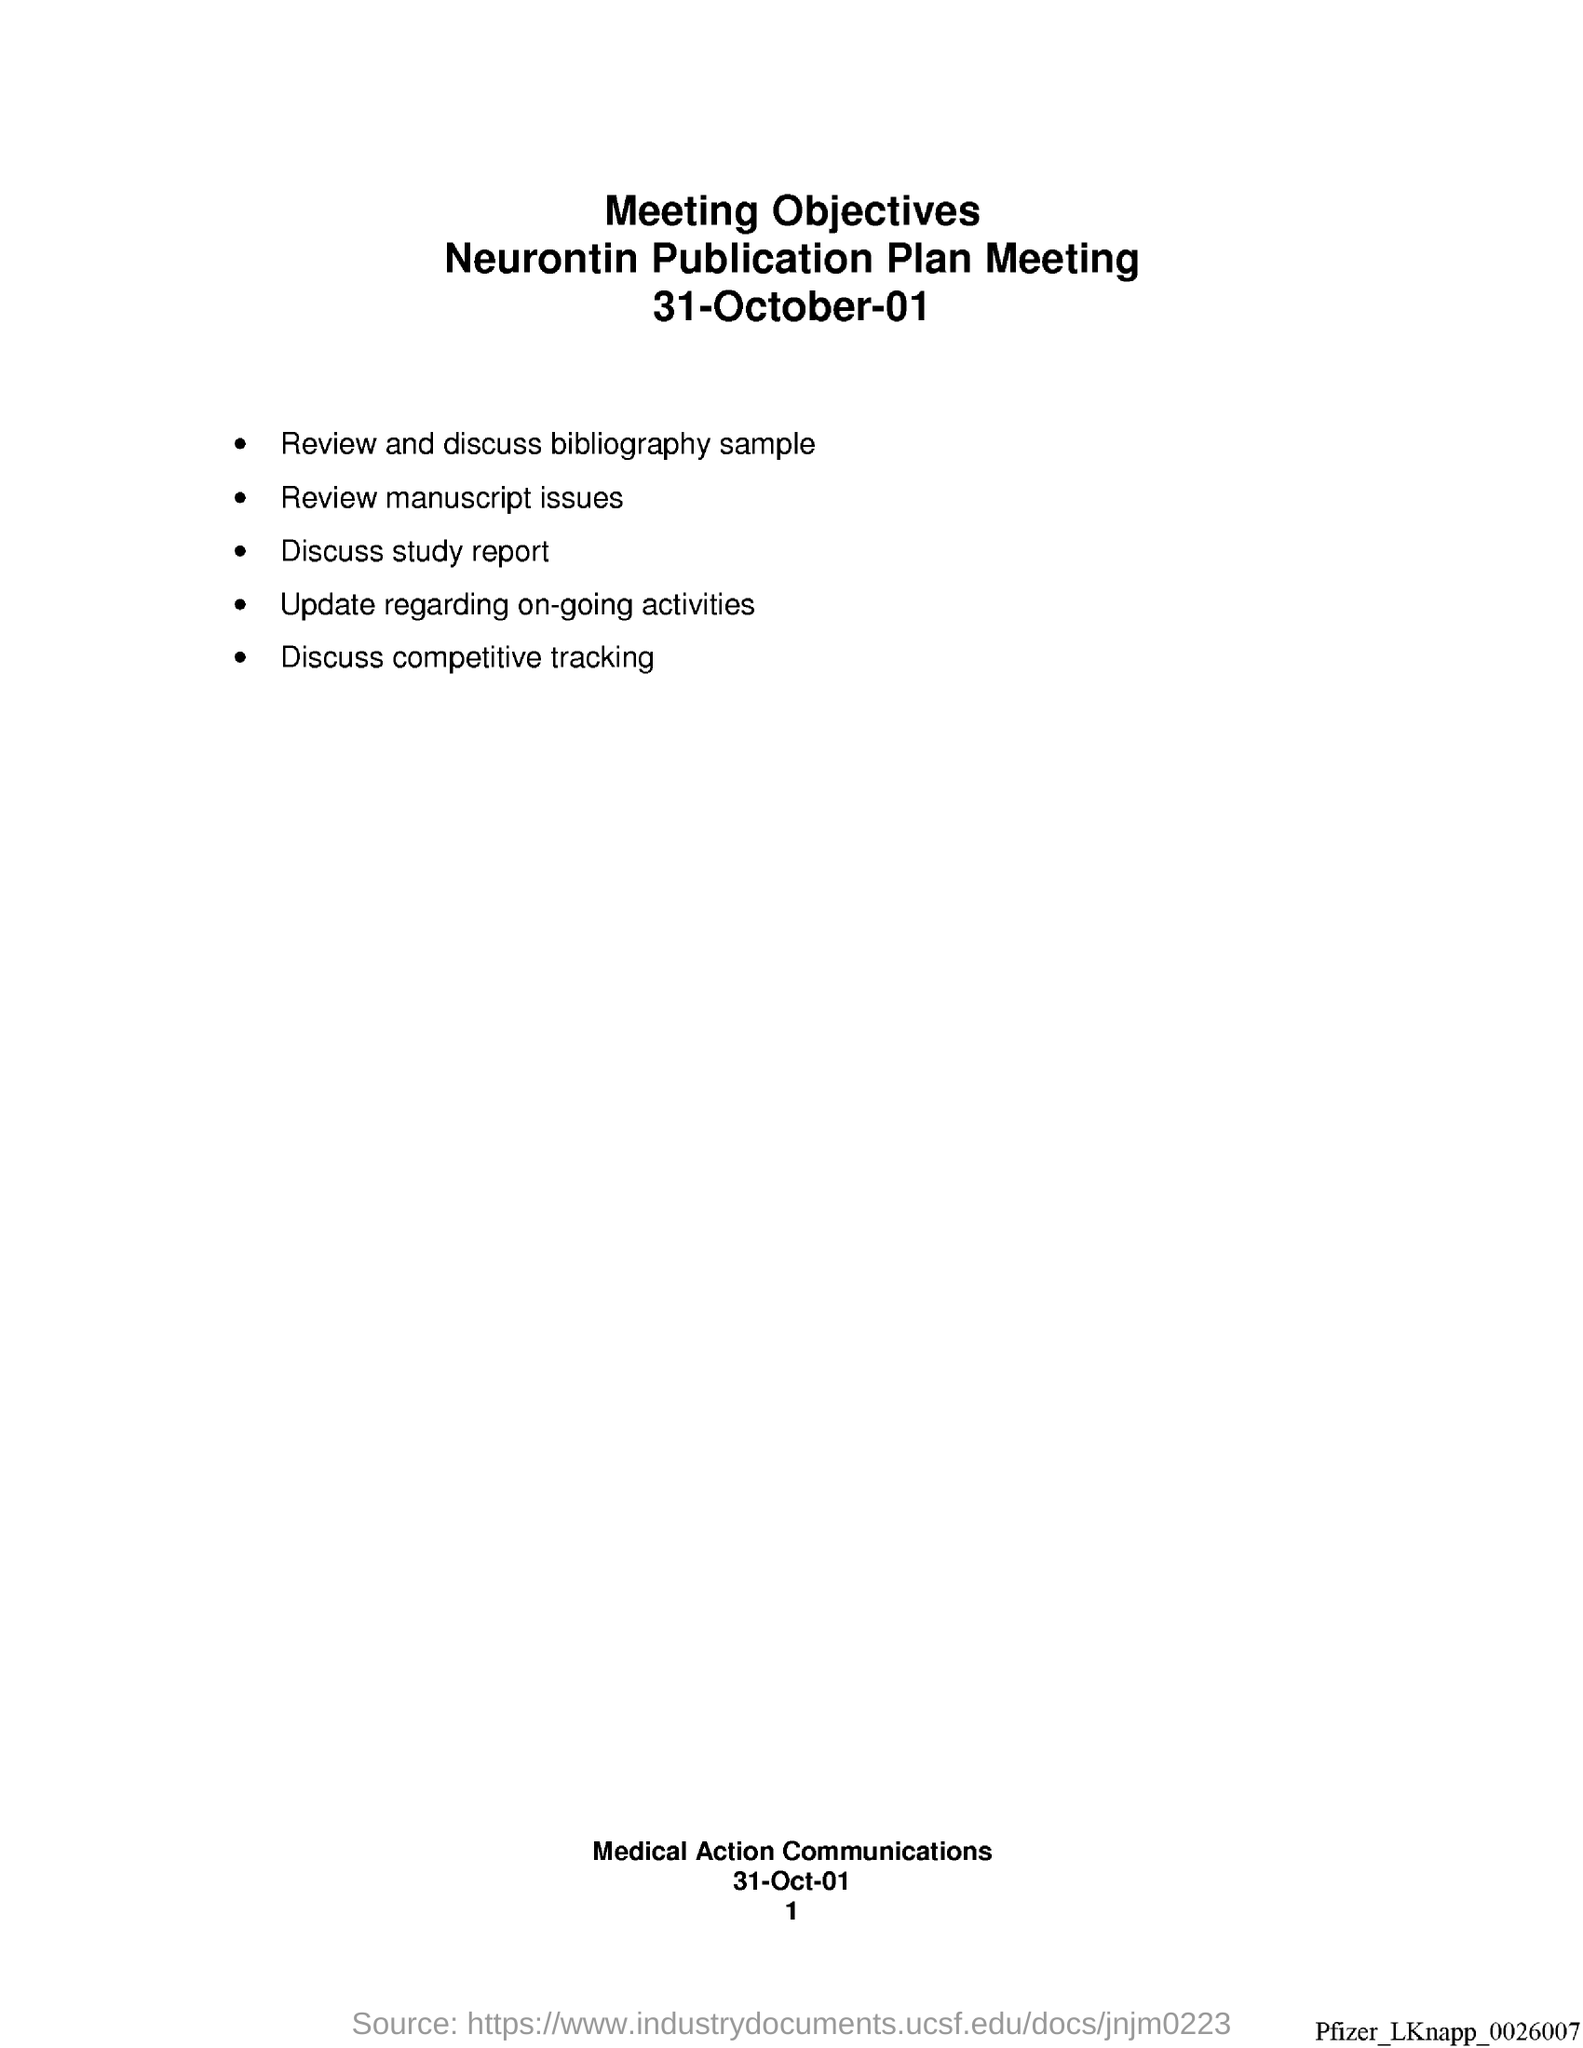What is the date at bottom of the page?
Make the answer very short. 31-Oct-01. What is the page number at bottom of the page?
Offer a terse response. 1. 